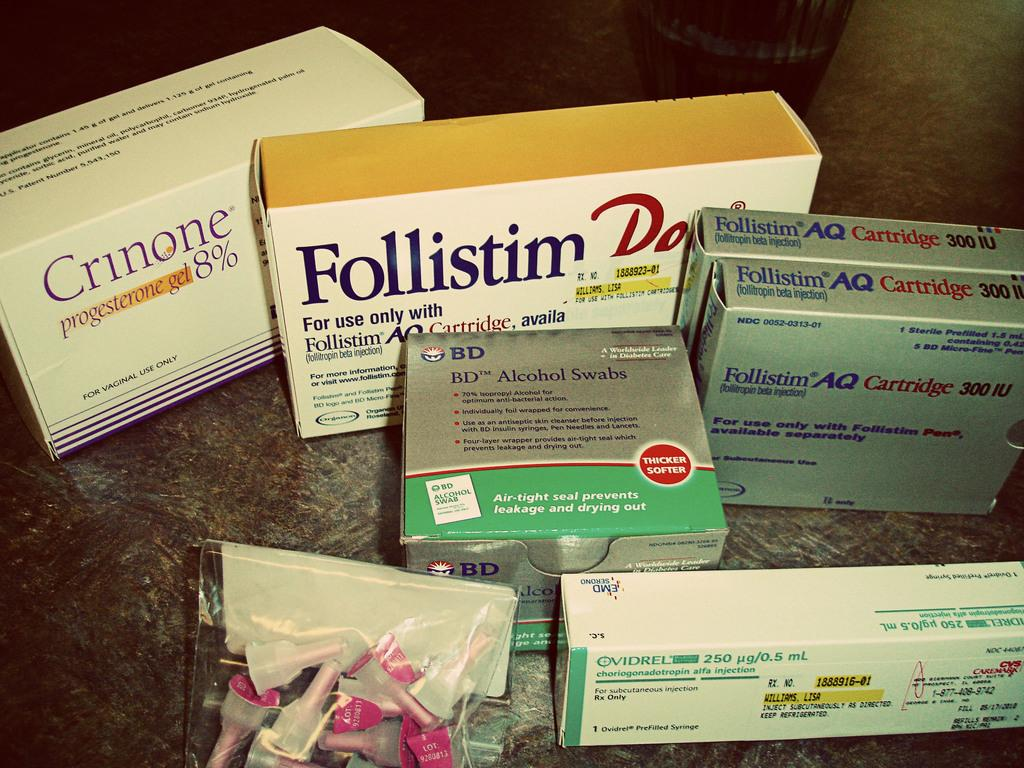Provide a one-sentence caption for the provided image. Several prescriptions sit on a countertop including "Crinone 8%". 